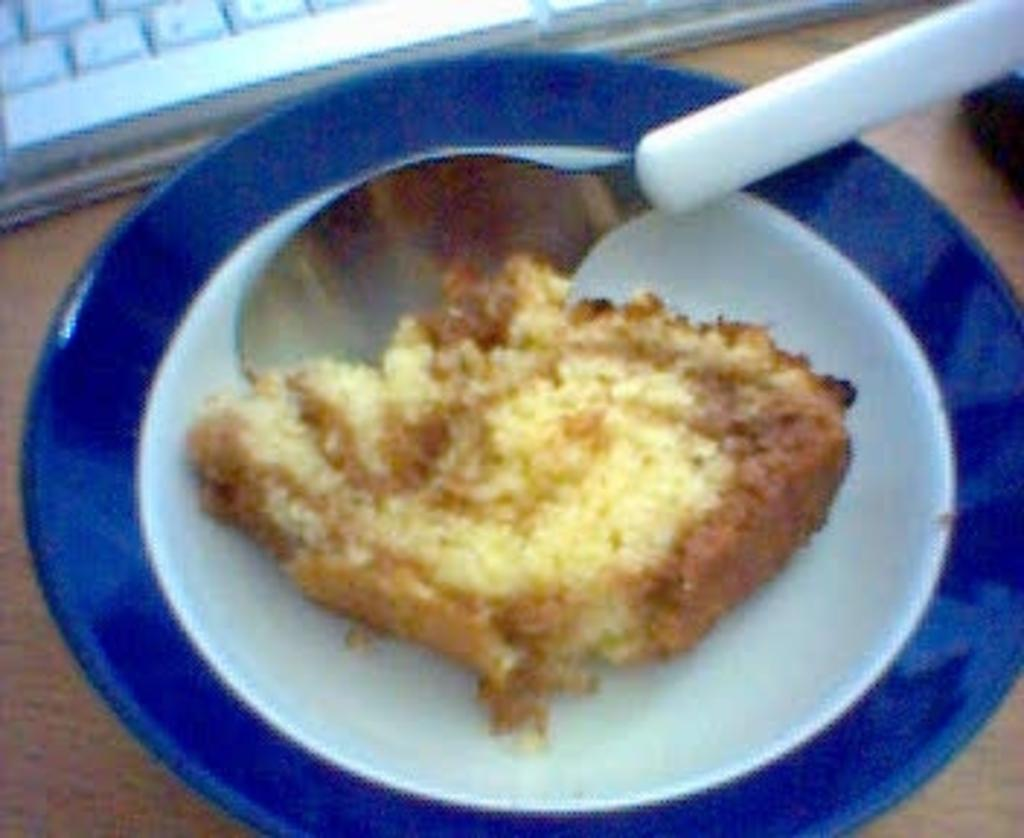What is on the plate in the image? There is a food item on a plate in the image. What utensil is placed with the food item on the plate? There is a spoon on the plate in the image. On what surface is the plate placed? The plate is placed on a wooden surface. What can be seen at the top of the image? There is a keyboard visible at the top of the image. What type of plane is flying over the food in the image? There is no plane visible in the image; it only shows a food item on a plate with a spoon on a wooden surface and a keyboard at the top. 